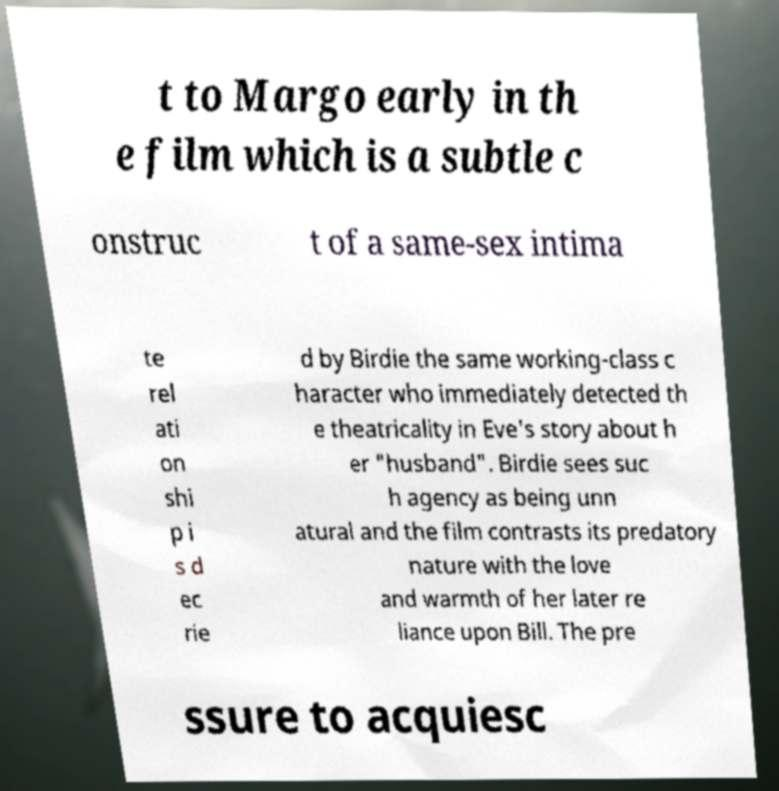Can you read and provide the text displayed in the image?This photo seems to have some interesting text. Can you extract and type it out for me? t to Margo early in th e film which is a subtle c onstruc t of a same-sex intima te rel ati on shi p i s d ec rie d by Birdie the same working-class c haracter who immediately detected th e theatricality in Eve's story about h er "husband". Birdie sees suc h agency as being unn atural and the film contrasts its predatory nature with the love and warmth of her later re liance upon Bill. The pre ssure to acquiesc 